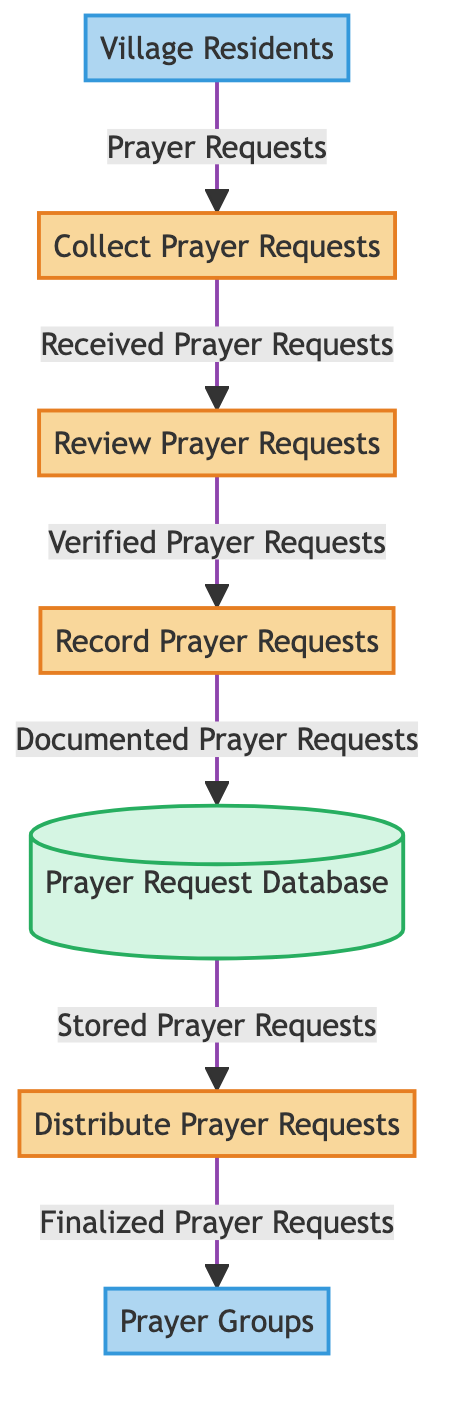What is the first process in the diagram? The first process is indicated by the label "Collect Prayer Requests", which is the starting point in the flow of handling prayer requests.
Answer: Collect Prayer Requests How many external entities are present in the diagram? The diagram shows two external entities: "Village Residents" and "Prayer Groups", counted at the start and end of the data flow.
Answer: 2 What type of data flows from the "Village Residents" to the "Collect Prayer Requests"? The data flow is indicated with the label "Prayer Requests", showing what is being sent from the external entity to the first process.
Answer: Prayer Requests Which process is responsible for documenting the prayer requests? "Record Prayer Requests" process is specifically tasked with documenting the verified requests before they are stored in the database.
Answer: Record Prayer Requests What happens to the verified prayer requests after the "Review Prayer Requests" process? The verified prayer requests move on to the "Record Prayer Requests" process, indicating the next step to take place after review.
Answer: Record Prayer Requests What is the final destination of the prayer requests before they reach the prayer groups? The prayer requests are stored in the "Prayer Request Database" before the distribution occurs, serving as the crucial data repository.
Answer: Prayer Request Database What type of data is stored in the "Prayer Request Database"? The database contains "Documented Prayer Requests," which are the inputs received from the previous processes, ensuring proper record-keeping.
Answer: Documented Prayer Requests Which process is the last one in the chain? The last process in the workflow is "Distribute Prayer Requests", which indicates the final action taken for sharing the requests with prayer groups.
Answer: Distribute Prayer Requests How does the diagram flow from the "Prayer Request Database" to the final prayer groups? The flow from the database involves sending "Stored Prayer Requests" to the "Distribute Prayer Requests" process, which then forwards the finalized versions to the "Prayer Groups".
Answer: Stored Prayer Requests to Distribute Prayer Requests 